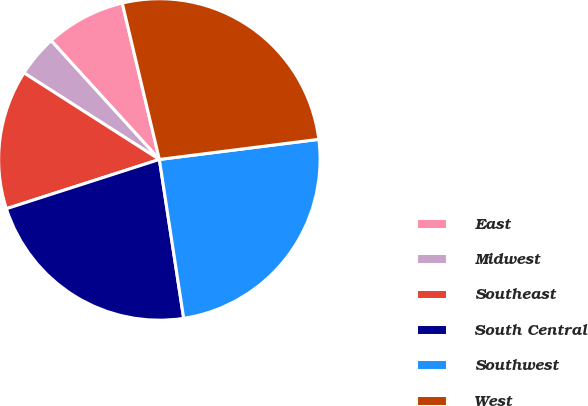<chart> <loc_0><loc_0><loc_500><loc_500><pie_chart><fcel>East<fcel>Midwest<fcel>Southeast<fcel>South Central<fcel>Southwest<fcel>West<nl><fcel>8.05%<fcel>4.19%<fcel>14.01%<fcel>22.46%<fcel>24.58%<fcel>26.71%<nl></chart> 